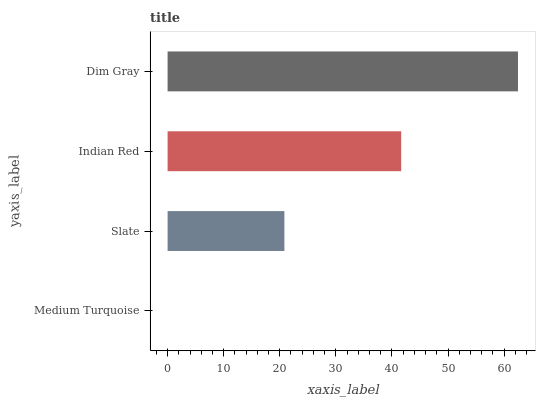Is Medium Turquoise the minimum?
Answer yes or no. Yes. Is Dim Gray the maximum?
Answer yes or no. Yes. Is Slate the minimum?
Answer yes or no. No. Is Slate the maximum?
Answer yes or no. No. Is Slate greater than Medium Turquoise?
Answer yes or no. Yes. Is Medium Turquoise less than Slate?
Answer yes or no. Yes. Is Medium Turquoise greater than Slate?
Answer yes or no. No. Is Slate less than Medium Turquoise?
Answer yes or no. No. Is Indian Red the high median?
Answer yes or no. Yes. Is Slate the low median?
Answer yes or no. Yes. Is Dim Gray the high median?
Answer yes or no. No. Is Indian Red the low median?
Answer yes or no. No. 